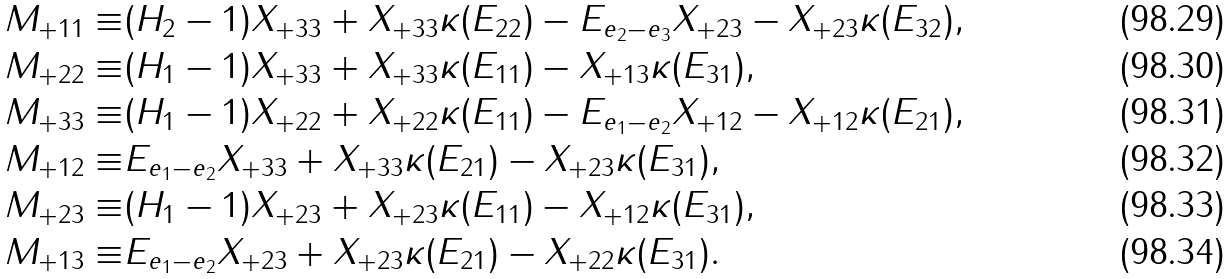Convert formula to latex. <formula><loc_0><loc_0><loc_500><loc_500>M _ { + 1 1 } \equiv & ( H _ { 2 } - 1 ) X _ { + 3 3 } + X _ { + 3 3 } \kappa ( E _ { 2 2 } ) - E _ { e _ { 2 } - e _ { 3 } } X _ { + 2 3 } - X _ { + 2 3 } \kappa ( E _ { 3 2 } ) , \\ M _ { + 2 2 } \equiv & ( H _ { 1 } - 1 ) X _ { + 3 3 } + X _ { + 3 3 } \kappa ( E _ { 1 1 } ) - X _ { + 1 3 } \kappa ( E _ { 3 1 } ) , \\ M _ { + 3 3 } \equiv & ( H _ { 1 } - 1 ) X _ { + 2 2 } + X _ { + 2 2 } \kappa ( E _ { 1 1 } ) - E _ { e _ { 1 } - e _ { 2 } } X _ { + 1 2 } - X _ { + 1 2 } \kappa ( E _ { 2 1 } ) , \\ M _ { + 1 2 } \equiv & E _ { e _ { 1 } - e _ { 2 } } X _ { + 3 3 } + X _ { + 3 3 } \kappa ( E _ { 2 1 } ) - X _ { + 2 3 } \kappa ( E _ { 3 1 } ) , \\ M _ { + 2 3 } \equiv & ( H _ { 1 } - 1 ) X _ { + 2 3 } + X _ { + 2 3 } \kappa ( E _ { 1 1 } ) - X _ { + 1 2 } \kappa ( E _ { 3 1 } ) , \\ M _ { + 1 3 } \equiv & E _ { e _ { 1 } - e _ { 2 } } X _ { + 2 3 } + X _ { + 2 3 } \kappa ( E _ { 2 1 } ) - X _ { + 2 2 } \kappa ( E _ { 3 1 } ) .</formula> 